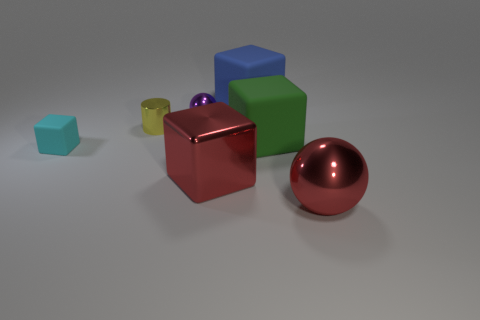Subtract 1 blocks. How many blocks are left? 3 Subtract all large shiny blocks. How many blocks are left? 3 Subtract all cyan blocks. How many blocks are left? 3 Add 3 tiny green objects. How many objects exist? 10 Subtract all brown cubes. Subtract all cyan balls. How many cubes are left? 4 Subtract all cylinders. How many objects are left? 6 Add 3 large metallic objects. How many large metallic objects are left? 5 Add 5 large metallic blocks. How many large metallic blocks exist? 6 Subtract 1 yellow cylinders. How many objects are left? 6 Subtract all blue metallic things. Subtract all red metal balls. How many objects are left? 6 